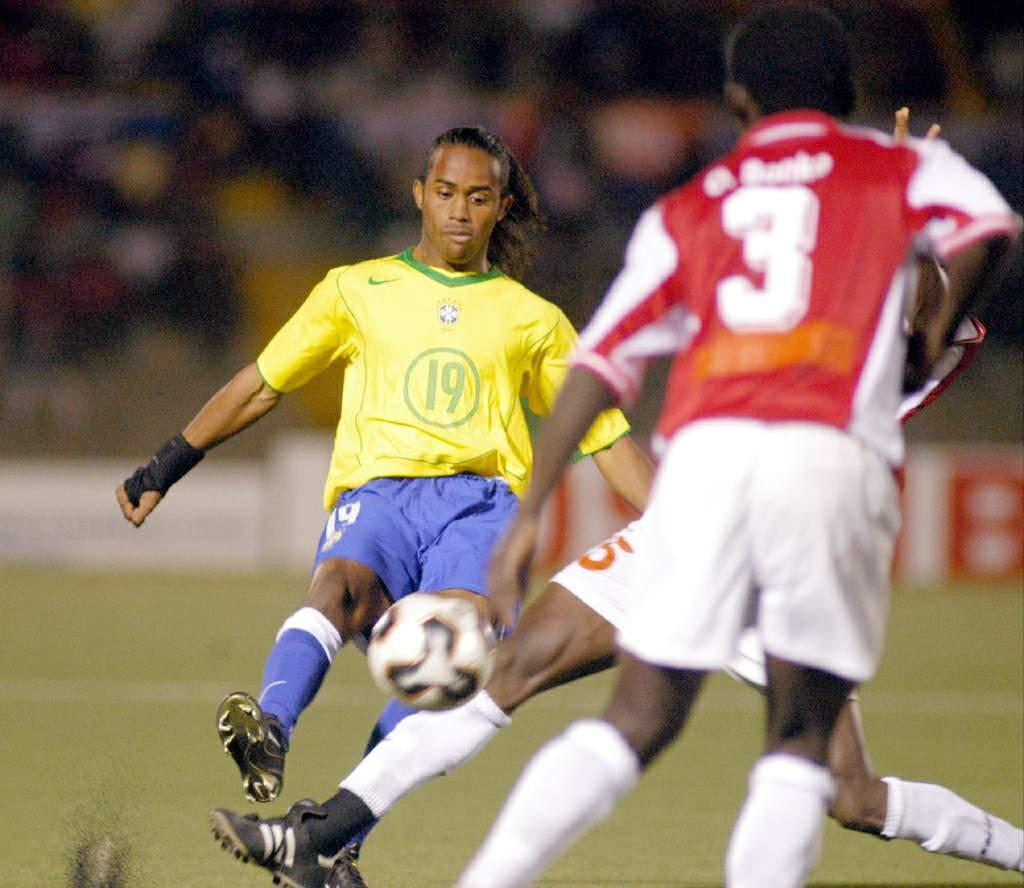How many people are in the image? There are three men in the image. What are the men doing in the image? The men are playing football. What type of surface are they playing on? There is a ground in the image. What invention can be seen in the hands of the men while they are playing football? There is no invention visible in the hands of the men while they are playing football; they are simply playing with a football. 